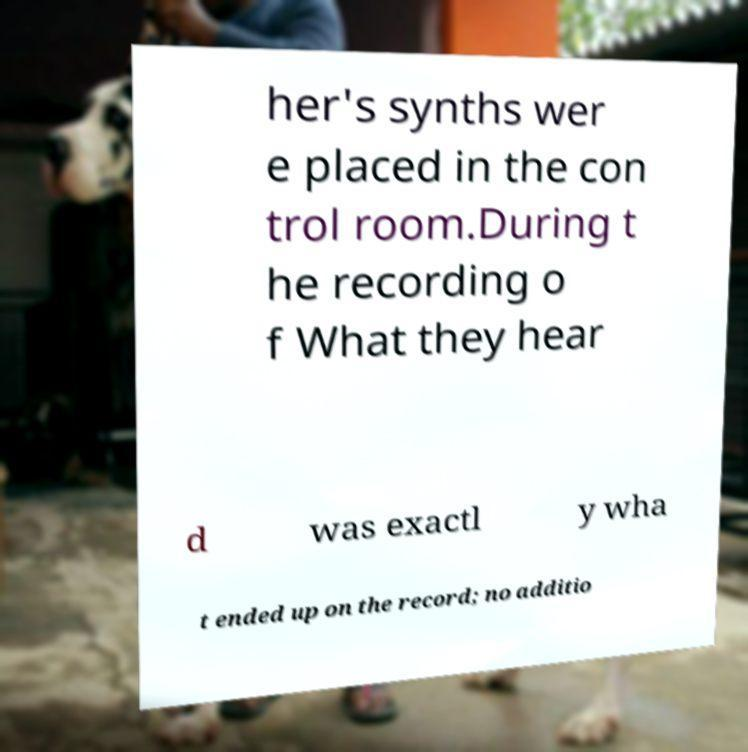For documentation purposes, I need the text within this image transcribed. Could you provide that? her's synths wer e placed in the con trol room.During t he recording o f What they hear d was exactl y wha t ended up on the record; no additio 